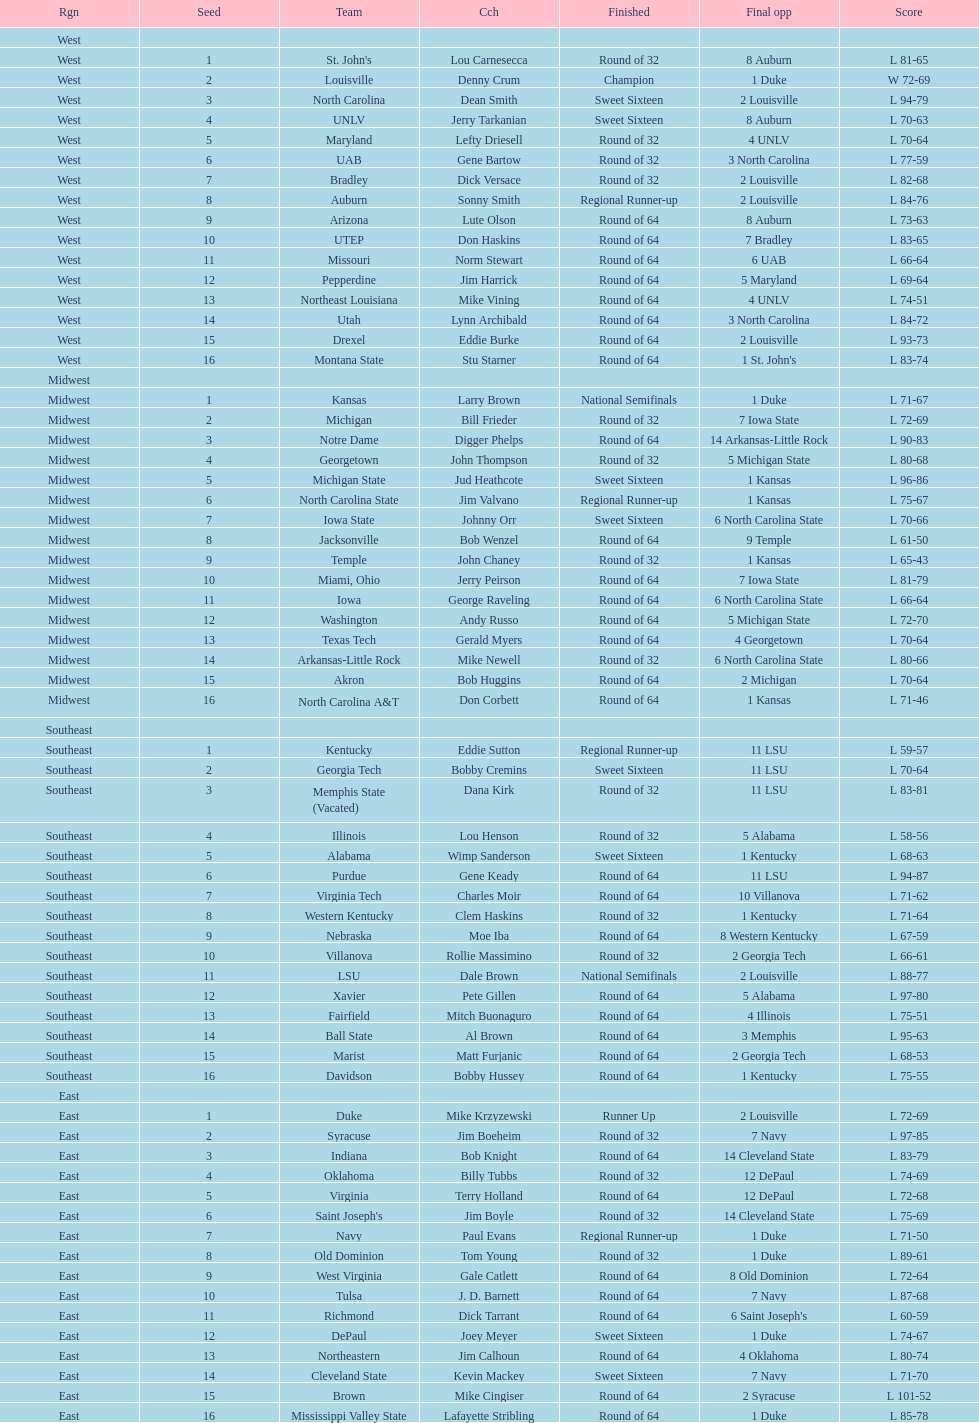How many teams are in the east region. 16. 